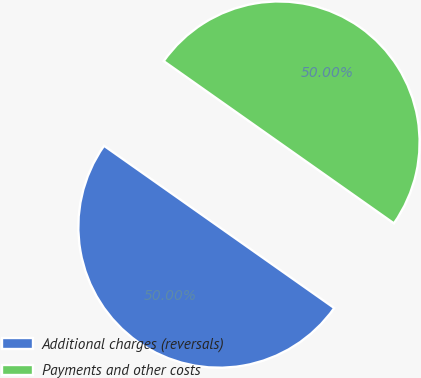<chart> <loc_0><loc_0><loc_500><loc_500><pie_chart><fcel>Additional charges (reversals)<fcel>Payments and other costs<nl><fcel>50.0%<fcel>50.0%<nl></chart> 